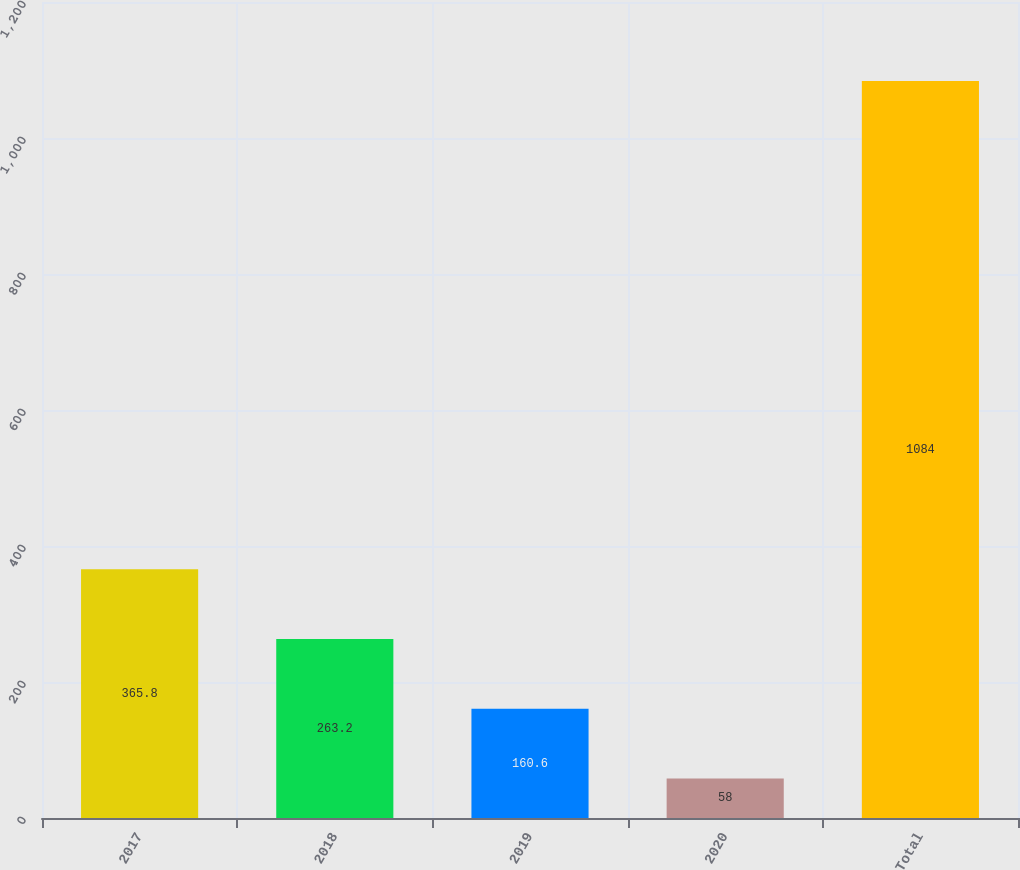Convert chart to OTSL. <chart><loc_0><loc_0><loc_500><loc_500><bar_chart><fcel>2017<fcel>2018<fcel>2019<fcel>2020<fcel>Total<nl><fcel>365.8<fcel>263.2<fcel>160.6<fcel>58<fcel>1084<nl></chart> 